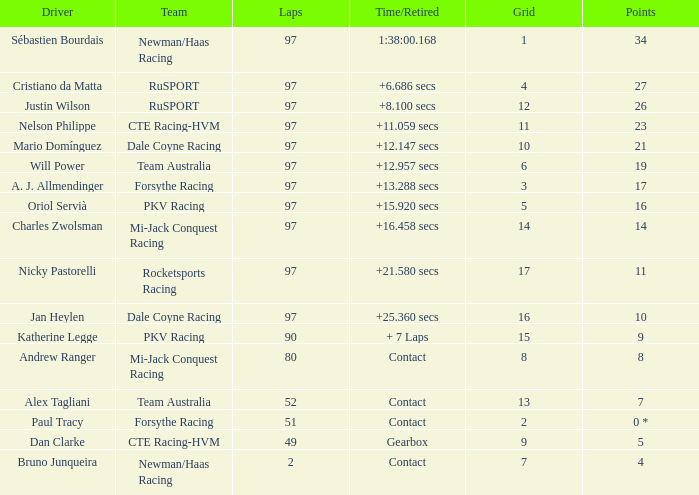What team does jan heylen race for? Dale Coyne Racing. 